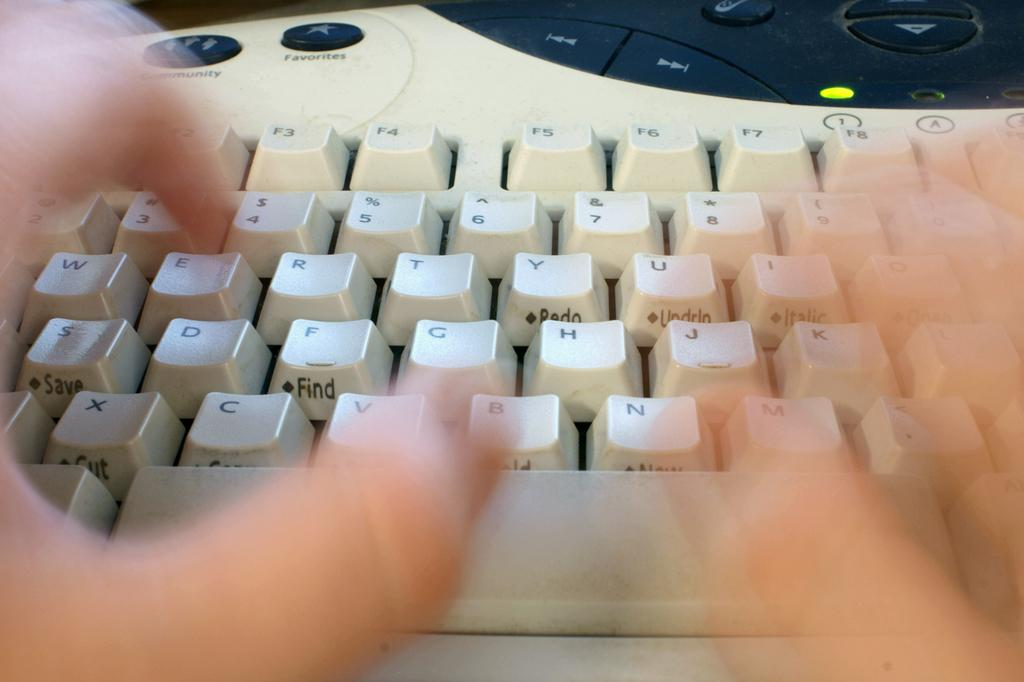<image>
Give a short and clear explanation of the subsequent image. A person types on a keyboard with a favorites star button. 